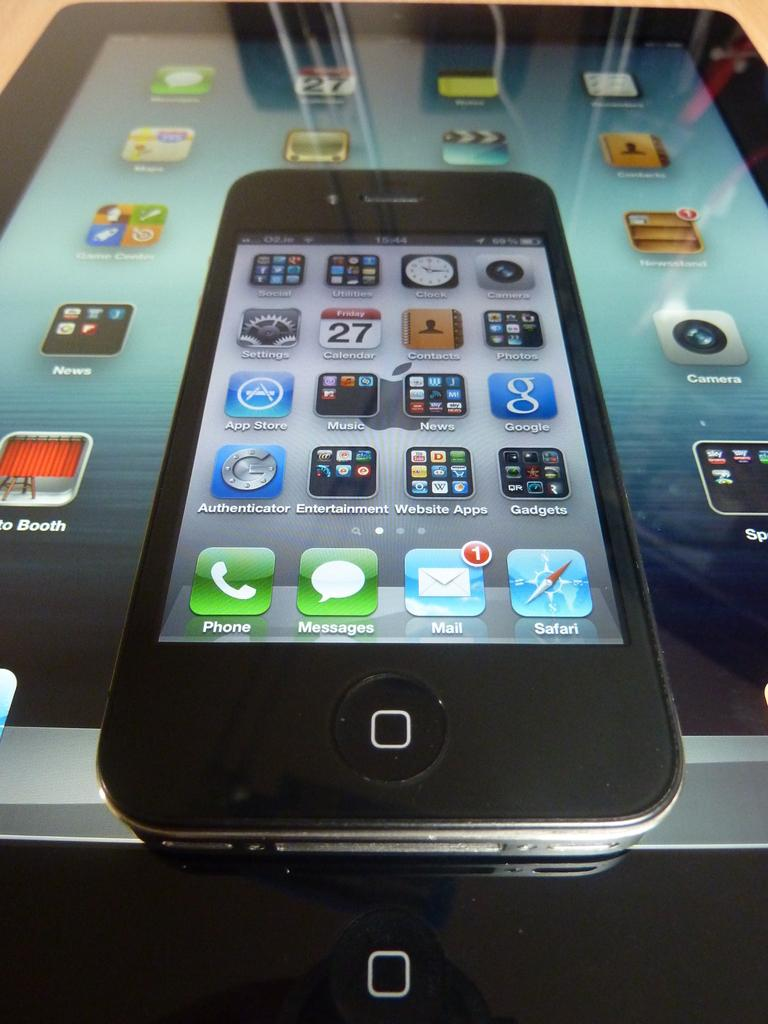Provide a one-sentence caption for the provided image. An iphone lays on top of an ipad, both with screens lit up and application icons visible. 